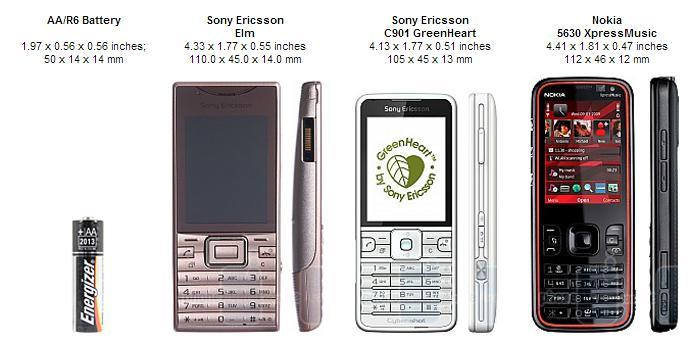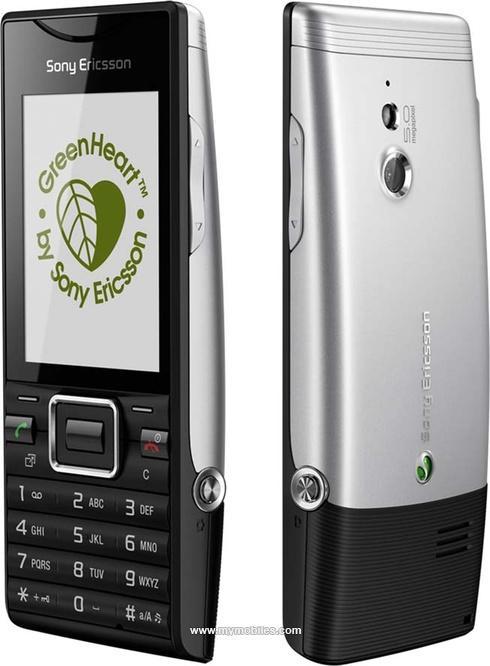The first image is the image on the left, the second image is the image on the right. Analyze the images presented: Is the assertion "The left and right image contains the same number of phones." valid? Answer yes or no. No. 